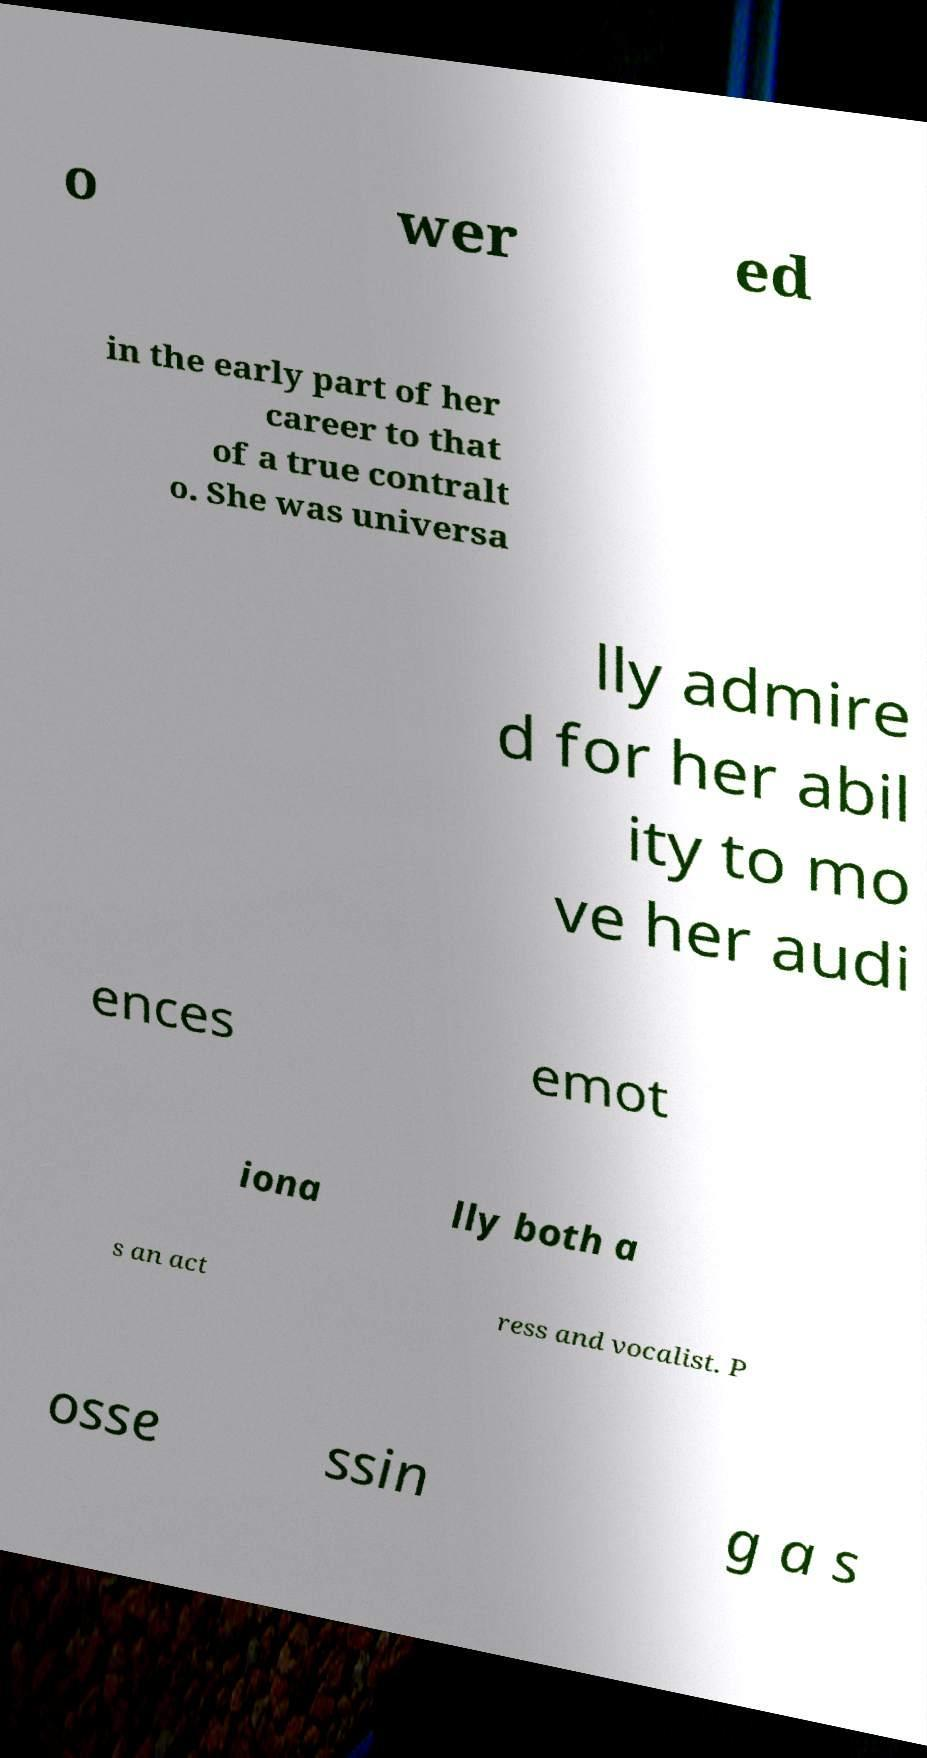Could you extract and type out the text from this image? o wer ed in the early part of her career to that of a true contralt o. She was universa lly admire d for her abil ity to mo ve her audi ences emot iona lly both a s an act ress and vocalist. P osse ssin g a s 